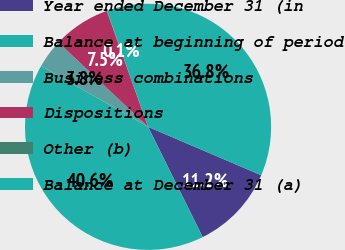Convert chart to OTSL. <chart><loc_0><loc_0><loc_500><loc_500><pie_chart><fcel>Year ended December 31 (in<fcel>Balance at beginning of period<fcel>Business combinations<fcel>Dispositions<fcel>Other (b)<fcel>Balance at December 31 (a)<nl><fcel>11.24%<fcel>40.56%<fcel>3.79%<fcel>7.52%<fcel>0.06%<fcel>36.83%<nl></chart> 